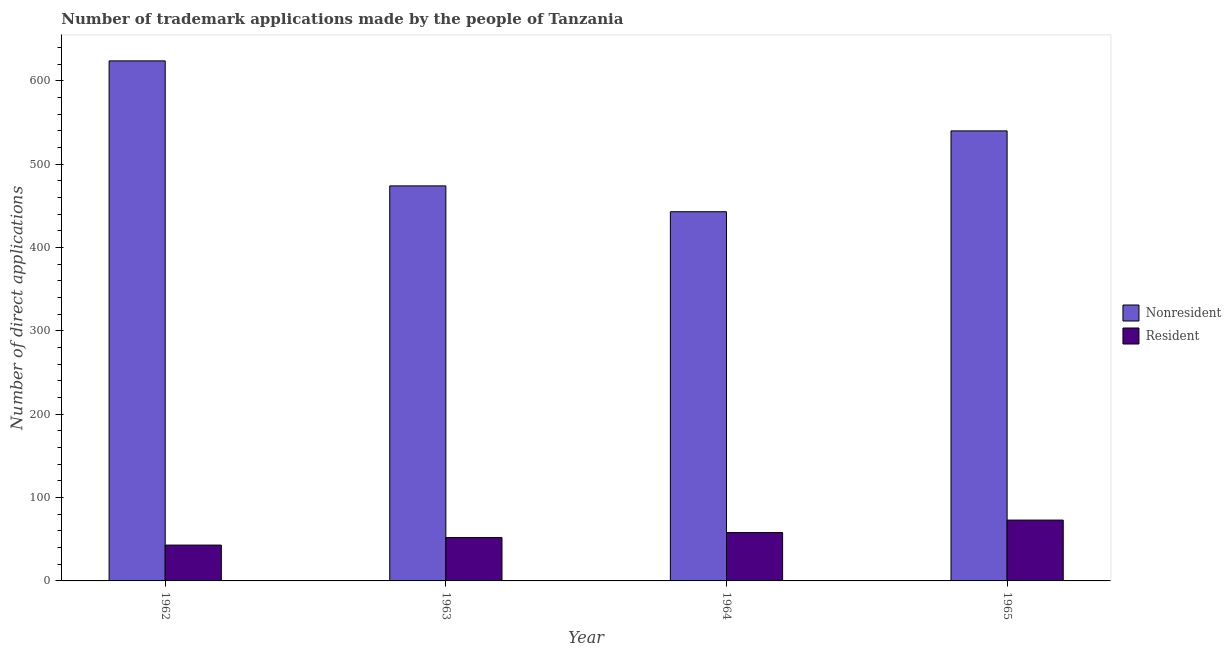What is the label of the 3rd group of bars from the left?
Keep it short and to the point. 1964. In how many cases, is the number of bars for a given year not equal to the number of legend labels?
Ensure brevity in your answer.  0. What is the number of trademark applications made by non residents in 1962?
Keep it short and to the point. 624. Across all years, what is the maximum number of trademark applications made by residents?
Give a very brief answer. 73. Across all years, what is the minimum number of trademark applications made by non residents?
Your answer should be compact. 443. In which year was the number of trademark applications made by residents minimum?
Your answer should be very brief. 1962. What is the total number of trademark applications made by non residents in the graph?
Provide a succinct answer. 2081. What is the difference between the number of trademark applications made by non residents in 1962 and that in 1963?
Ensure brevity in your answer.  150. What is the difference between the number of trademark applications made by residents in 1963 and the number of trademark applications made by non residents in 1964?
Offer a very short reply. -6. What is the average number of trademark applications made by non residents per year?
Provide a short and direct response. 520.25. In how many years, is the number of trademark applications made by residents greater than 360?
Offer a very short reply. 0. What is the ratio of the number of trademark applications made by residents in 1962 to that in 1963?
Provide a succinct answer. 0.83. What is the difference between the highest and the second highest number of trademark applications made by non residents?
Make the answer very short. 84. What is the difference between the highest and the lowest number of trademark applications made by residents?
Provide a short and direct response. 30. In how many years, is the number of trademark applications made by residents greater than the average number of trademark applications made by residents taken over all years?
Ensure brevity in your answer.  2. What does the 2nd bar from the left in 1963 represents?
Your answer should be compact. Resident. What does the 1st bar from the right in 1962 represents?
Make the answer very short. Resident. How many years are there in the graph?
Ensure brevity in your answer.  4. What is the difference between two consecutive major ticks on the Y-axis?
Make the answer very short. 100. Does the graph contain any zero values?
Your answer should be compact. No. Does the graph contain grids?
Make the answer very short. No. Where does the legend appear in the graph?
Keep it short and to the point. Center right. How many legend labels are there?
Your response must be concise. 2. What is the title of the graph?
Your response must be concise. Number of trademark applications made by the people of Tanzania. What is the label or title of the Y-axis?
Your response must be concise. Number of direct applications. What is the Number of direct applications in Nonresident in 1962?
Provide a succinct answer. 624. What is the Number of direct applications in Nonresident in 1963?
Provide a short and direct response. 474. What is the Number of direct applications of Nonresident in 1964?
Make the answer very short. 443. What is the Number of direct applications of Resident in 1964?
Offer a very short reply. 58. What is the Number of direct applications in Nonresident in 1965?
Your response must be concise. 540. What is the Number of direct applications in Resident in 1965?
Keep it short and to the point. 73. Across all years, what is the maximum Number of direct applications of Nonresident?
Ensure brevity in your answer.  624. Across all years, what is the minimum Number of direct applications of Nonresident?
Your response must be concise. 443. Across all years, what is the minimum Number of direct applications in Resident?
Make the answer very short. 43. What is the total Number of direct applications of Nonresident in the graph?
Offer a very short reply. 2081. What is the total Number of direct applications in Resident in the graph?
Offer a terse response. 226. What is the difference between the Number of direct applications in Nonresident in 1962 and that in 1963?
Your answer should be compact. 150. What is the difference between the Number of direct applications in Nonresident in 1962 and that in 1964?
Your answer should be compact. 181. What is the difference between the Number of direct applications of Resident in 1962 and that in 1964?
Keep it short and to the point. -15. What is the difference between the Number of direct applications of Resident in 1962 and that in 1965?
Keep it short and to the point. -30. What is the difference between the Number of direct applications in Nonresident in 1963 and that in 1964?
Make the answer very short. 31. What is the difference between the Number of direct applications in Resident in 1963 and that in 1964?
Make the answer very short. -6. What is the difference between the Number of direct applications of Nonresident in 1963 and that in 1965?
Provide a succinct answer. -66. What is the difference between the Number of direct applications of Nonresident in 1964 and that in 1965?
Offer a very short reply. -97. What is the difference between the Number of direct applications in Resident in 1964 and that in 1965?
Your answer should be compact. -15. What is the difference between the Number of direct applications in Nonresident in 1962 and the Number of direct applications in Resident in 1963?
Give a very brief answer. 572. What is the difference between the Number of direct applications in Nonresident in 1962 and the Number of direct applications in Resident in 1964?
Your response must be concise. 566. What is the difference between the Number of direct applications in Nonresident in 1962 and the Number of direct applications in Resident in 1965?
Your response must be concise. 551. What is the difference between the Number of direct applications in Nonresident in 1963 and the Number of direct applications in Resident in 1964?
Make the answer very short. 416. What is the difference between the Number of direct applications of Nonresident in 1963 and the Number of direct applications of Resident in 1965?
Offer a very short reply. 401. What is the difference between the Number of direct applications in Nonresident in 1964 and the Number of direct applications in Resident in 1965?
Provide a short and direct response. 370. What is the average Number of direct applications in Nonresident per year?
Provide a short and direct response. 520.25. What is the average Number of direct applications of Resident per year?
Your response must be concise. 56.5. In the year 1962, what is the difference between the Number of direct applications of Nonresident and Number of direct applications of Resident?
Give a very brief answer. 581. In the year 1963, what is the difference between the Number of direct applications of Nonresident and Number of direct applications of Resident?
Provide a short and direct response. 422. In the year 1964, what is the difference between the Number of direct applications of Nonresident and Number of direct applications of Resident?
Your answer should be compact. 385. In the year 1965, what is the difference between the Number of direct applications in Nonresident and Number of direct applications in Resident?
Your answer should be compact. 467. What is the ratio of the Number of direct applications of Nonresident in 1962 to that in 1963?
Your answer should be compact. 1.32. What is the ratio of the Number of direct applications of Resident in 1962 to that in 1963?
Give a very brief answer. 0.83. What is the ratio of the Number of direct applications of Nonresident in 1962 to that in 1964?
Offer a very short reply. 1.41. What is the ratio of the Number of direct applications in Resident in 1962 to that in 1964?
Provide a short and direct response. 0.74. What is the ratio of the Number of direct applications of Nonresident in 1962 to that in 1965?
Provide a short and direct response. 1.16. What is the ratio of the Number of direct applications in Resident in 1962 to that in 1965?
Your answer should be very brief. 0.59. What is the ratio of the Number of direct applications of Nonresident in 1963 to that in 1964?
Your answer should be very brief. 1.07. What is the ratio of the Number of direct applications of Resident in 1963 to that in 1964?
Your answer should be compact. 0.9. What is the ratio of the Number of direct applications of Nonresident in 1963 to that in 1965?
Your answer should be compact. 0.88. What is the ratio of the Number of direct applications in Resident in 1963 to that in 1965?
Your answer should be compact. 0.71. What is the ratio of the Number of direct applications of Nonresident in 1964 to that in 1965?
Make the answer very short. 0.82. What is the ratio of the Number of direct applications in Resident in 1964 to that in 1965?
Offer a very short reply. 0.79. What is the difference between the highest and the second highest Number of direct applications in Nonresident?
Keep it short and to the point. 84. What is the difference between the highest and the lowest Number of direct applications in Nonresident?
Make the answer very short. 181. 